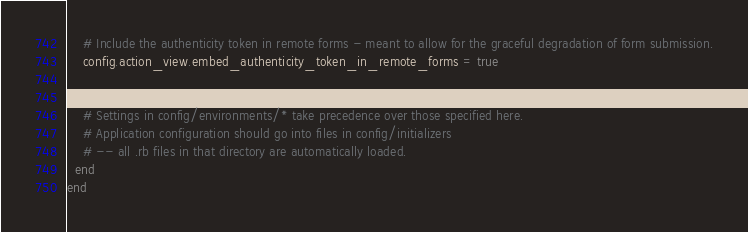<code> <loc_0><loc_0><loc_500><loc_500><_Ruby_>

    # Include the authenticity token in remote forms - meant to allow for the graceful degradation of form submission.
    config.action_view.embed_authenticity_token_in_remote_forms = true

    
    # Settings in config/environments/* take precedence over those specified here.
    # Application configuration should go into files in config/initializers
    # -- all .rb files in that directory are automatically loaded.
  end
end
</code> 